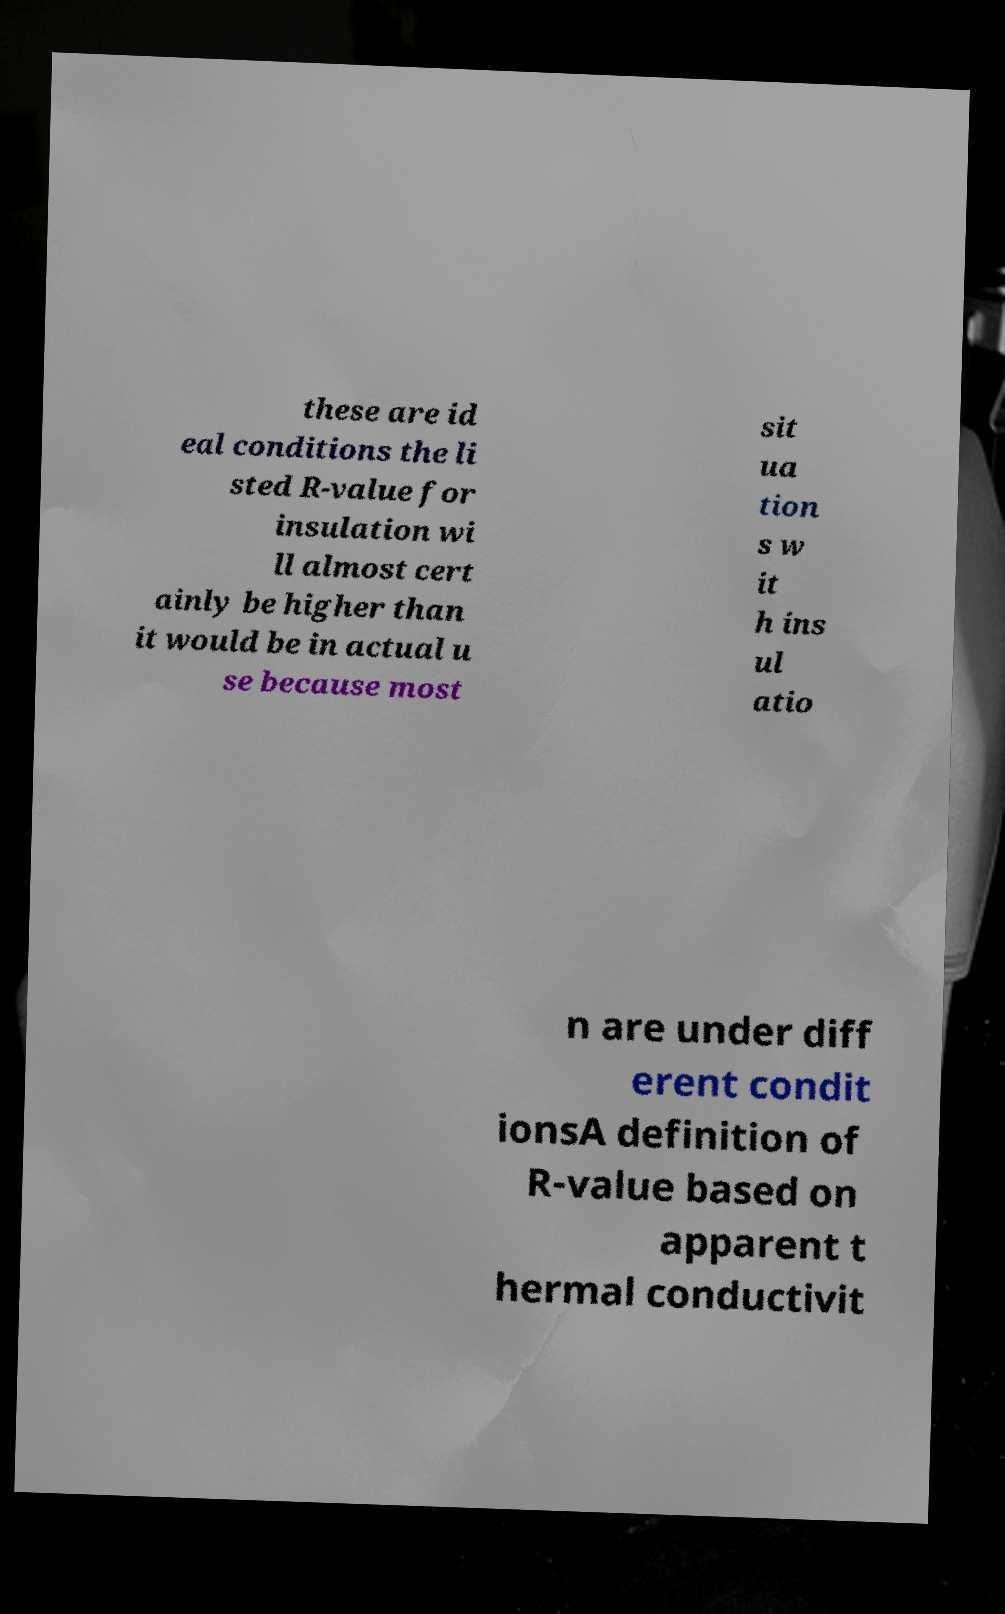For documentation purposes, I need the text within this image transcribed. Could you provide that? these are id eal conditions the li sted R-value for insulation wi ll almost cert ainly be higher than it would be in actual u se because most sit ua tion s w it h ins ul atio n are under diff erent condit ionsA definition of R-value based on apparent t hermal conductivit 